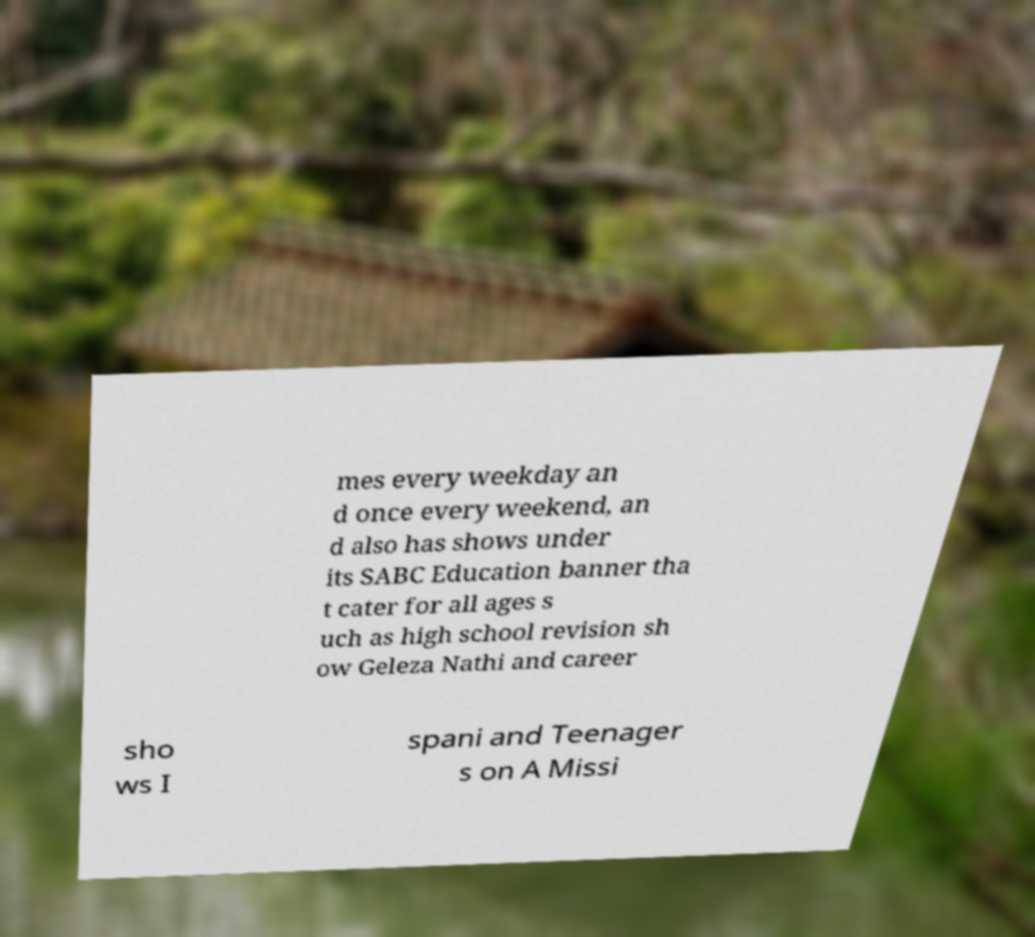Could you assist in decoding the text presented in this image and type it out clearly? mes every weekday an d once every weekend, an d also has shows under its SABC Education banner tha t cater for all ages s uch as high school revision sh ow Geleza Nathi and career sho ws I spani and Teenager s on A Missi 